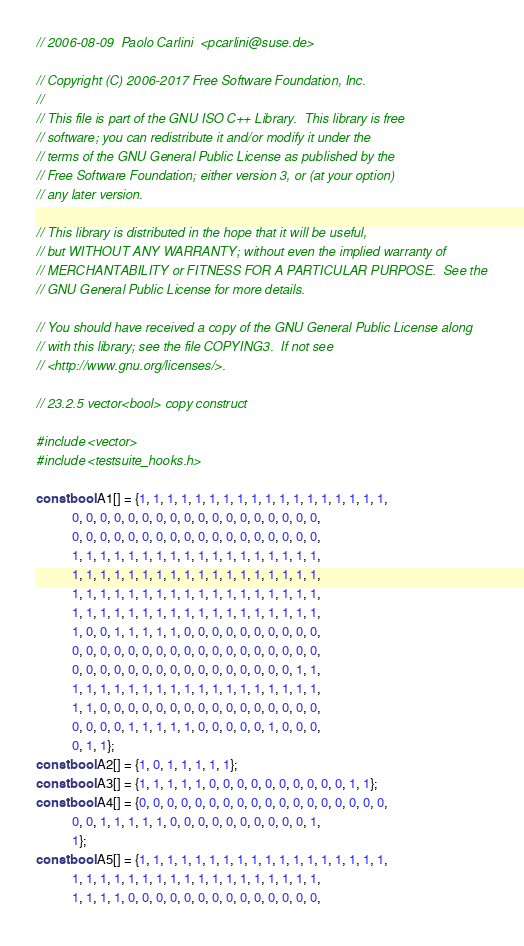<code> <loc_0><loc_0><loc_500><loc_500><_C++_>// 2006-08-09  Paolo Carlini  <pcarlini@suse.de>

// Copyright (C) 2006-2017 Free Software Foundation, Inc.
//
// This file is part of the GNU ISO C++ Library.  This library is free
// software; you can redistribute it and/or modify it under the
// terms of the GNU General Public License as published by the
// Free Software Foundation; either version 3, or (at your option)
// any later version.

// This library is distributed in the hope that it will be useful,
// but WITHOUT ANY WARRANTY; without even the implied warranty of
// MERCHANTABILITY or FITNESS FOR A PARTICULAR PURPOSE.  See the
// GNU General Public License for more details.

// You should have received a copy of the GNU General Public License along
// with this library; see the file COPYING3.  If not see
// <http://www.gnu.org/licenses/>.

// 23.2.5 vector<bool> copy construct

#include <vector>
#include <testsuite_hooks.h>

const bool A1[] = {1, 1, 1, 1, 1, 1, 1, 1, 1, 1, 1, 1, 1, 1, 1, 1, 1, 1,
		   0, 0, 0, 0, 0, 0, 0, 0, 0, 0, 0, 0, 0, 0, 0, 0, 0, 0,
		   0, 0, 0, 0, 0, 0, 0, 0, 0, 0, 0, 0, 0, 0, 0, 0, 0, 0,
		   1, 1, 1, 1, 1, 1, 1, 1, 1, 1, 1, 1, 1, 1, 1, 1, 1, 1,
		   1, 1, 1, 1, 1, 1, 1, 1, 1, 1, 1, 1, 1, 1, 1, 1, 1, 1,
		   1, 1, 1, 1, 1, 1, 1, 1, 1, 1, 1, 1, 1, 1, 1, 1, 1, 1,
		   1, 1, 1, 1, 1, 1, 1, 1, 1, 1, 1, 1, 1, 1, 1, 1, 1, 1,
		   1, 0, 0, 1, 1, 1, 1, 1, 0, 0, 0, 0, 0, 0, 0, 0, 0, 0,
		   0, 0, 0, 0, 0, 0, 0, 0, 0, 0, 0, 0, 0, 0, 0, 0, 0, 0,
		   0, 0, 0, 0, 0, 0, 0, 0, 0, 0, 0, 0, 0, 0, 0, 0, 1, 1,
		   1, 1, 1, 1, 1, 1, 1, 1, 1, 1, 1, 1, 1, 1, 1, 1, 1, 1,
		   1, 1, 0, 0, 0, 0, 0, 0, 0, 0, 0, 0, 0, 0, 0, 0, 0, 0,
		   0, 0, 0, 0, 1, 1, 1, 1, 1, 0, 0, 0, 0, 0, 1, 0, 0, 0,
		   0, 1, 1};
const bool A2[] = {1, 0, 1, 1, 1, 1, 1};
const bool A3[] = {1, 1, 1, 1, 1, 0, 0, 0, 0, 0, 0, 0, 0, 0, 0, 1, 1};
const bool A4[] = {0, 0, 0, 0, 0, 0, 0, 0, 0, 0, 0, 0, 0, 0, 0, 0, 0, 0,
		   0, 0, 1, 1, 1, 1, 1, 0, 0, 0, 0, 0, 0, 0, 0, 0, 0, 1,
		   1};
const bool A5[] = {1, 1, 1, 1, 1, 1, 1, 1, 1, 1, 1, 1, 1, 1, 1, 1, 1, 1,
		   1, 1, 1, 1, 1, 1, 1, 1, 1, 1, 1, 1, 1, 1, 1, 1, 1, 1,
		   1, 1, 1, 1, 0, 0, 0, 0, 0, 0, 0, 0, 0, 0, 0, 0, 0, 0,</code> 